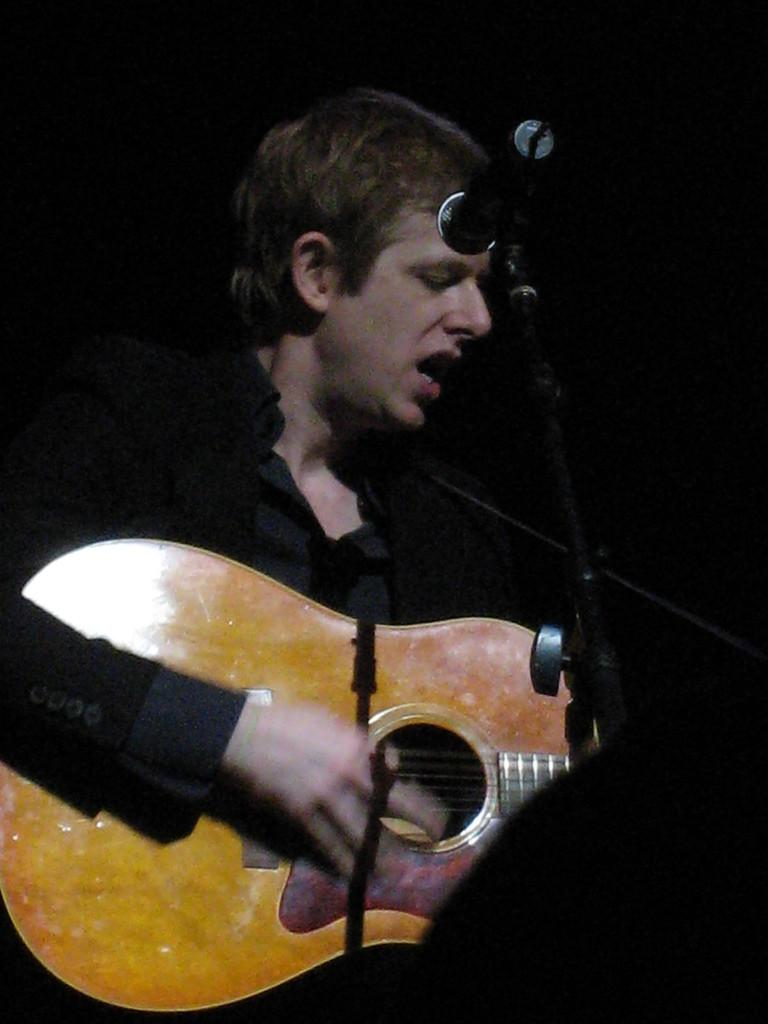What is the person in the image wearing? The person is wearing a black suit. What is the person holding in the image? The person is holding a guitar. What is the person doing with the guitar? The person is playing the guitar. What is present in the image that might be used for amplifying sound? There is a microphone in the image. What type of disease is the person in the image suffering from? There is no indication of any disease in the image; the person is simply playing the guitar. What is the rate of the guitar strings in the image? The image does not provide information about the rate of the guitar strings; it only shows the person playing the guitar. 